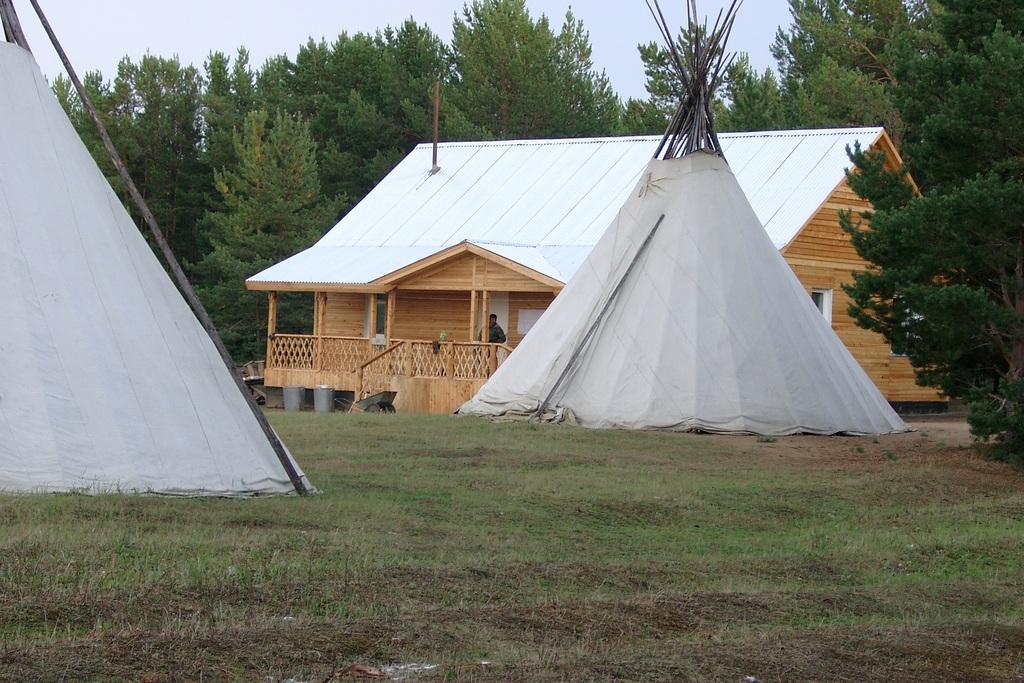Describe this image in one or two sentences. In the center of the image there is a shed and we can see a man standing in the shed. At the bottom there are tents. In the background there are trees and sky. 